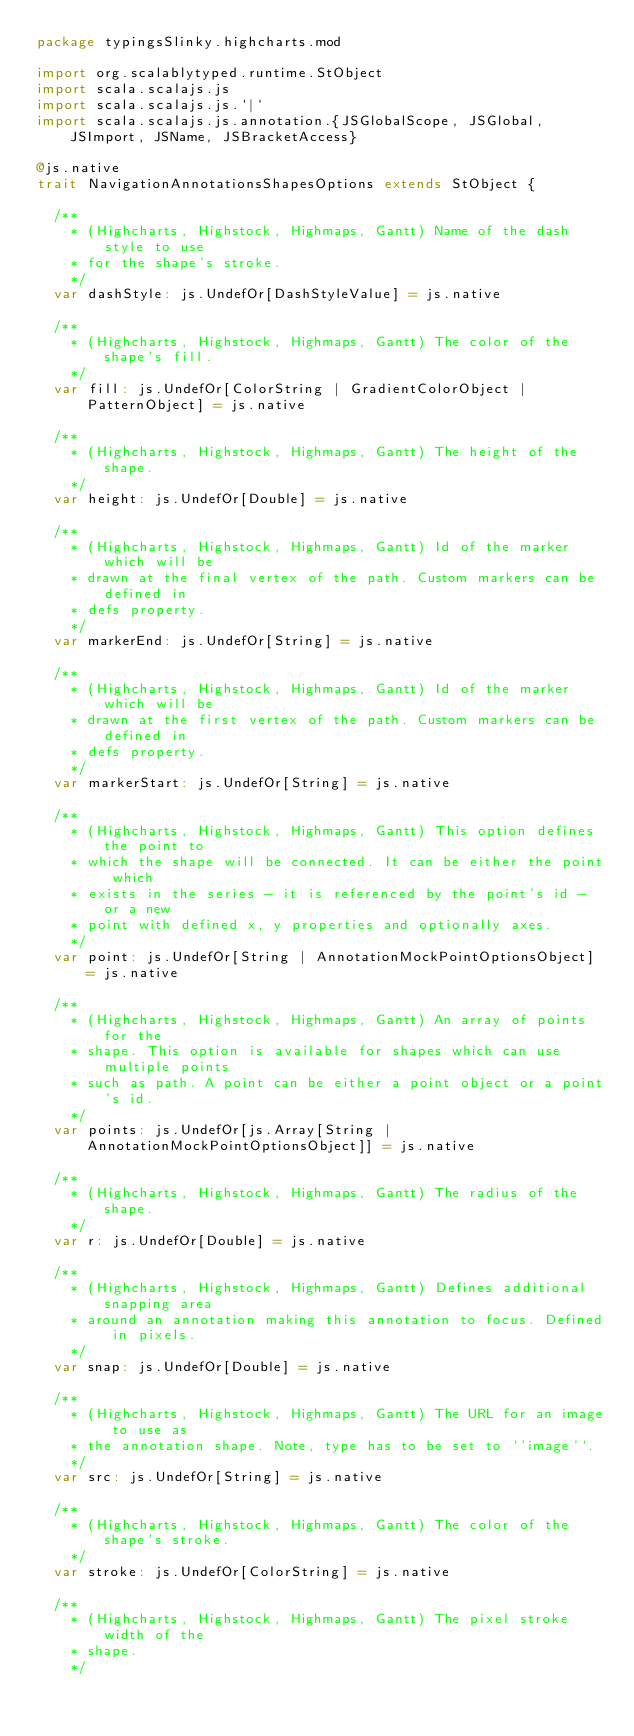Convert code to text. <code><loc_0><loc_0><loc_500><loc_500><_Scala_>package typingsSlinky.highcharts.mod

import org.scalablytyped.runtime.StObject
import scala.scalajs.js
import scala.scalajs.js.`|`
import scala.scalajs.js.annotation.{JSGlobalScope, JSGlobal, JSImport, JSName, JSBracketAccess}

@js.native
trait NavigationAnnotationsShapesOptions extends StObject {
  
  /**
    * (Highcharts, Highstock, Highmaps, Gantt) Name of the dash style to use
    * for the shape's stroke.
    */
  var dashStyle: js.UndefOr[DashStyleValue] = js.native
  
  /**
    * (Highcharts, Highstock, Highmaps, Gantt) The color of the shape's fill.
    */
  var fill: js.UndefOr[ColorString | GradientColorObject | PatternObject] = js.native
  
  /**
    * (Highcharts, Highstock, Highmaps, Gantt) The height of the shape.
    */
  var height: js.UndefOr[Double] = js.native
  
  /**
    * (Highcharts, Highstock, Highmaps, Gantt) Id of the marker which will be
    * drawn at the final vertex of the path. Custom markers can be defined in
    * defs property.
    */
  var markerEnd: js.UndefOr[String] = js.native
  
  /**
    * (Highcharts, Highstock, Highmaps, Gantt) Id of the marker which will be
    * drawn at the first vertex of the path. Custom markers can be defined in
    * defs property.
    */
  var markerStart: js.UndefOr[String] = js.native
  
  /**
    * (Highcharts, Highstock, Highmaps, Gantt) This option defines the point to
    * which the shape will be connected. It can be either the point which
    * exists in the series - it is referenced by the point's id - or a new
    * point with defined x, y properties and optionally axes.
    */
  var point: js.UndefOr[String | AnnotationMockPointOptionsObject] = js.native
  
  /**
    * (Highcharts, Highstock, Highmaps, Gantt) An array of points for the
    * shape. This option is available for shapes which can use multiple points
    * such as path. A point can be either a point object or a point's id.
    */
  var points: js.UndefOr[js.Array[String | AnnotationMockPointOptionsObject]] = js.native
  
  /**
    * (Highcharts, Highstock, Highmaps, Gantt) The radius of the shape.
    */
  var r: js.UndefOr[Double] = js.native
  
  /**
    * (Highcharts, Highstock, Highmaps, Gantt) Defines additional snapping area
    * around an annotation making this annotation to focus. Defined in pixels.
    */
  var snap: js.UndefOr[Double] = js.native
  
  /**
    * (Highcharts, Highstock, Highmaps, Gantt) The URL for an image to use as
    * the annotation shape. Note, type has to be set to `'image'`.
    */
  var src: js.UndefOr[String] = js.native
  
  /**
    * (Highcharts, Highstock, Highmaps, Gantt) The color of the shape's stroke.
    */
  var stroke: js.UndefOr[ColorString] = js.native
  
  /**
    * (Highcharts, Highstock, Highmaps, Gantt) The pixel stroke width of the
    * shape.
    */</code> 